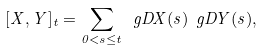Convert formula to latex. <formula><loc_0><loc_0><loc_500><loc_500>[ X , Y ] _ { t } = \sum _ { 0 < s \leq t } \ g D X ( s ) \ g D Y ( s ) ,</formula> 